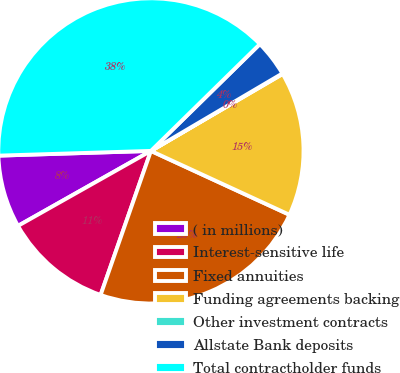<chart> <loc_0><loc_0><loc_500><loc_500><pie_chart><fcel>( in millions)<fcel>Interest-sensitive life<fcel>Fixed annuities<fcel>Funding agreements backing<fcel>Other investment contracts<fcel>Allstate Bank deposits<fcel>Total contractholder funds<nl><fcel>7.68%<fcel>11.48%<fcel>23.47%<fcel>15.29%<fcel>0.06%<fcel>3.87%<fcel>38.15%<nl></chart> 